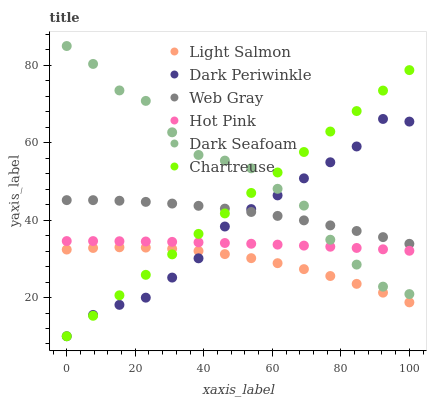Does Light Salmon have the minimum area under the curve?
Answer yes or no. Yes. Does Dark Seafoam have the maximum area under the curve?
Answer yes or no. Yes. Does Web Gray have the minimum area under the curve?
Answer yes or no. No. Does Web Gray have the maximum area under the curve?
Answer yes or no. No. Is Chartreuse the smoothest?
Answer yes or no. Yes. Is Dark Seafoam the roughest?
Answer yes or no. Yes. Is Web Gray the smoothest?
Answer yes or no. No. Is Web Gray the roughest?
Answer yes or no. No. Does Chartreuse have the lowest value?
Answer yes or no. Yes. Does Hot Pink have the lowest value?
Answer yes or no. No. Does Dark Seafoam have the highest value?
Answer yes or no. Yes. Does Web Gray have the highest value?
Answer yes or no. No. Is Light Salmon less than Web Gray?
Answer yes or no. Yes. Is Web Gray greater than Light Salmon?
Answer yes or no. Yes. Does Dark Seafoam intersect Hot Pink?
Answer yes or no. Yes. Is Dark Seafoam less than Hot Pink?
Answer yes or no. No. Is Dark Seafoam greater than Hot Pink?
Answer yes or no. No. Does Light Salmon intersect Web Gray?
Answer yes or no. No. 